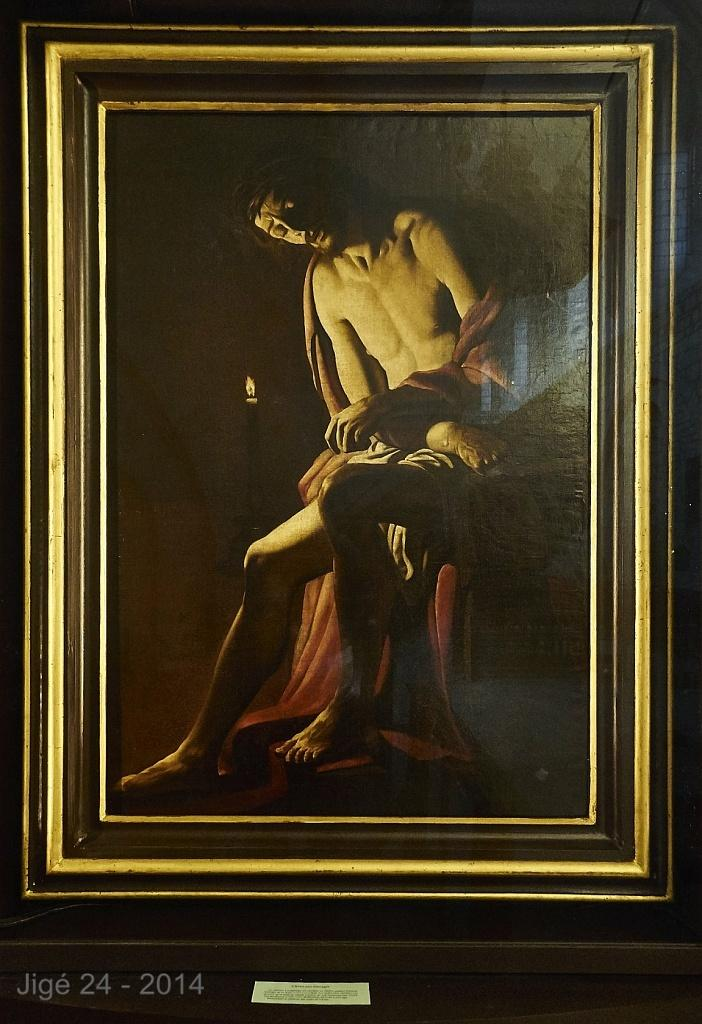<image>
Present a compact description of the photo's key features. A framed portrait of a man created in the year 2014. 